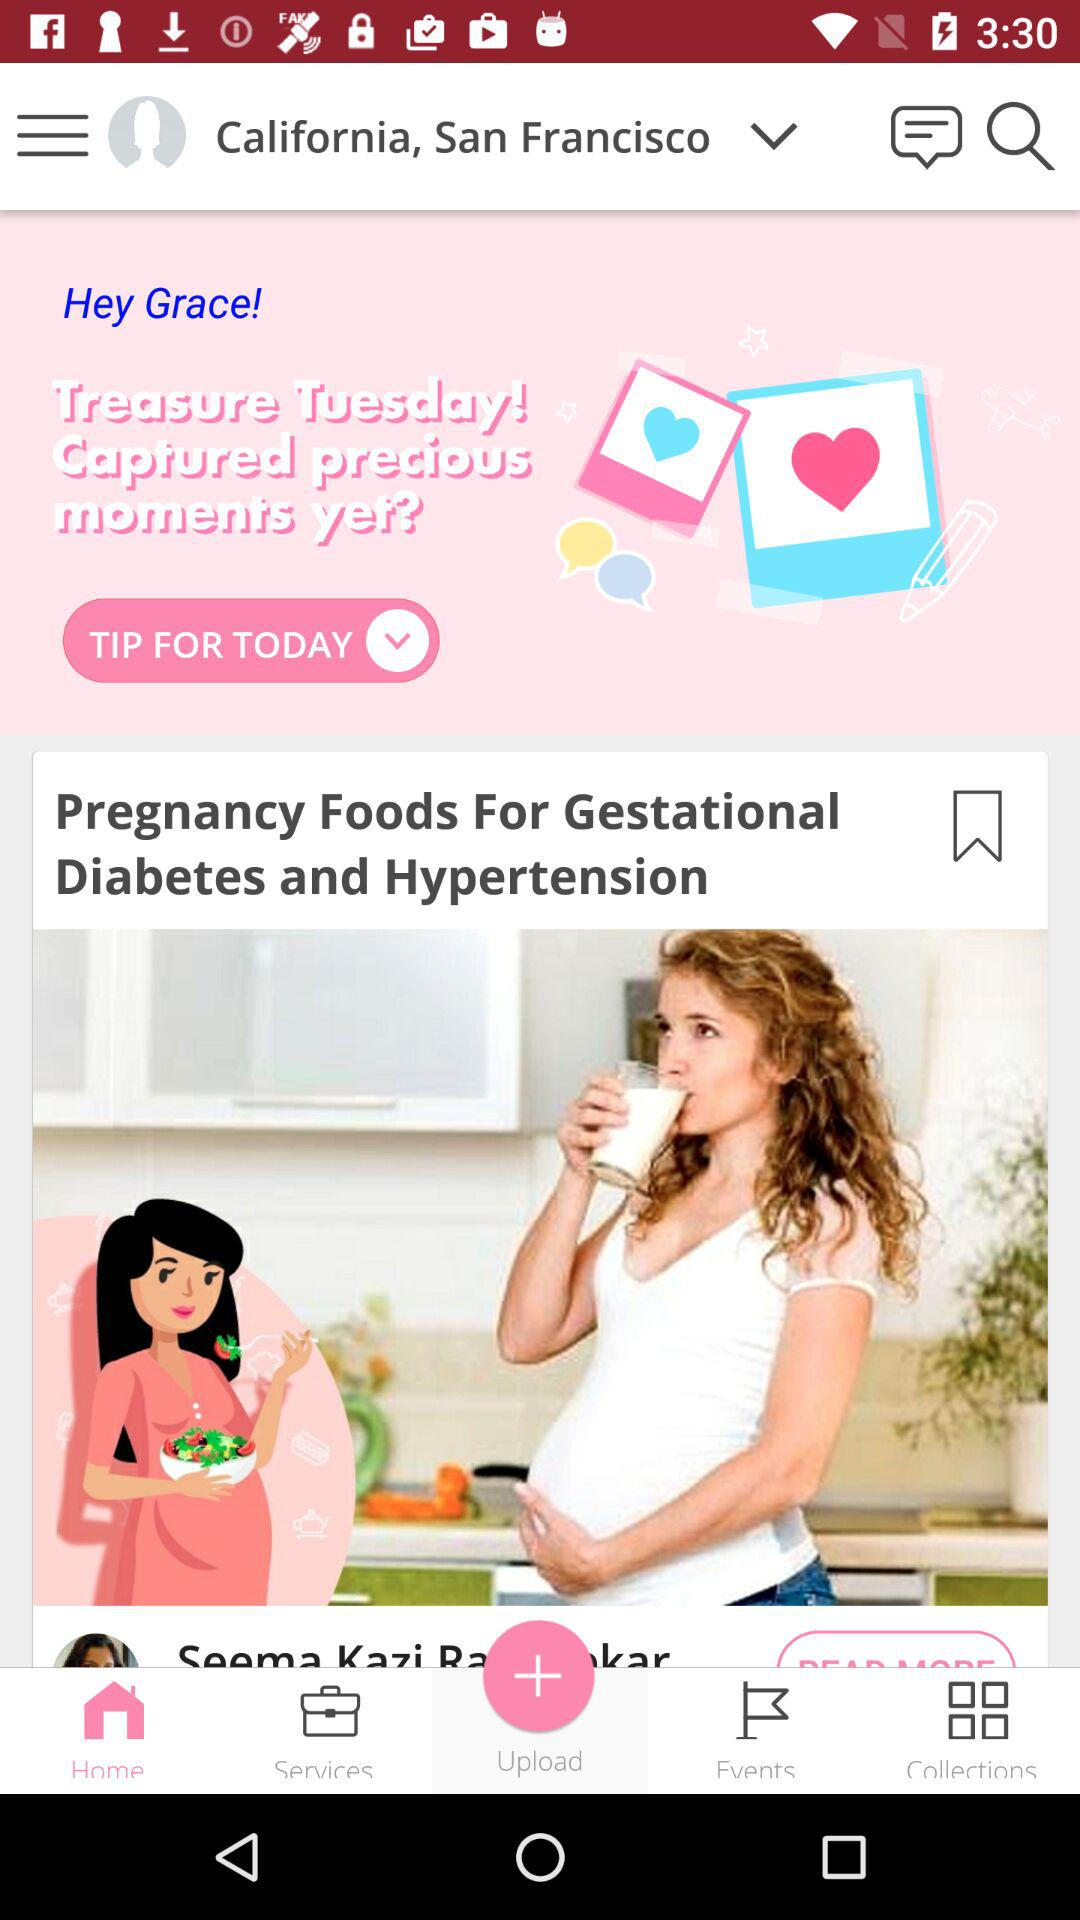Which location options are available in the drop-down menu?
When the provided information is insufficient, respond with <no answer>. <no answer> 